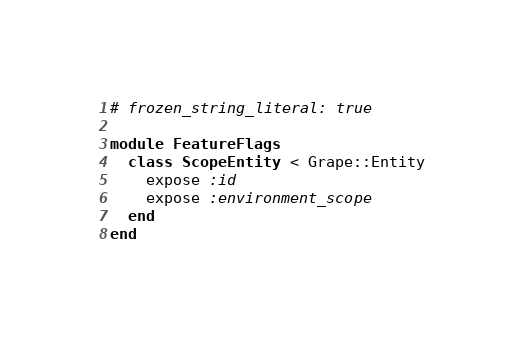Convert code to text. <code><loc_0><loc_0><loc_500><loc_500><_Ruby_># frozen_string_literal: true

module FeatureFlags
  class ScopeEntity < Grape::Entity
    expose :id
    expose :environment_scope
  end
end
</code> 